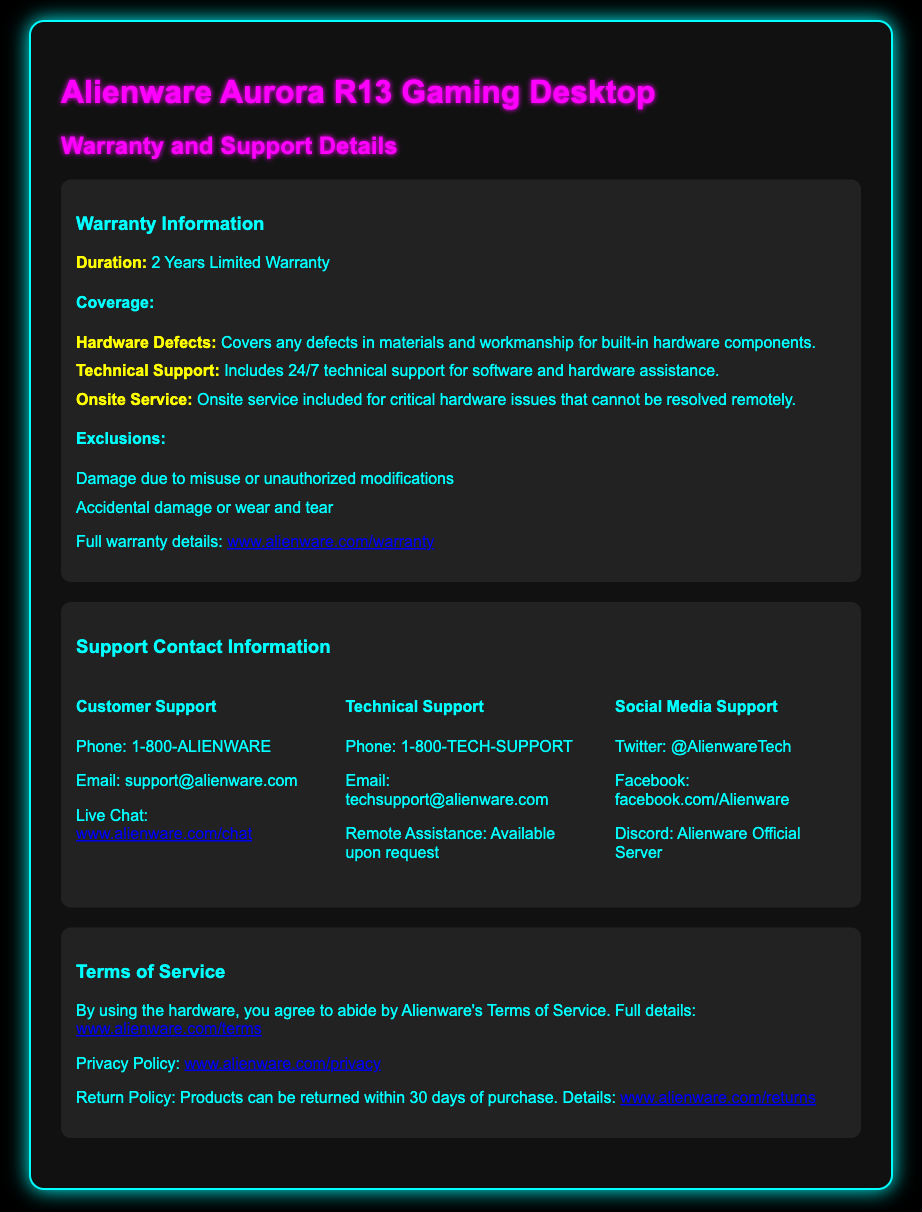What is the warranty duration? The warranty duration is specified in the document as 2 Years Limited Warranty.
Answer: 2 Years Limited Warranty What does the warranty cover? The document lists components covered by the warranty, including hardware defects and technical support.
Answer: Hardware Defects, Technical Support, Onsite Service What is excluded from the warranty coverage? The document outlines specific exclusions such as damage from misuse and accidental damage.
Answer: Damage due to misuse or unauthorized modifications, Accidental damage or wear and tear What is the phone number for Customer Support? The document provides the phone number for Customer Support as 1-800-ALIENWARE.
Answer: 1-800-ALIENWARE How many methods of contacting Technical Support are listed? The document includes various methods for contacting Technical Support including phone, email, and remote assistance.
Answer: 3 What is the return policy timeframe? The document specifies the timeframe for the return policy related to purchased products.
Answer: 30 days What does using the hardware require regarding Terms of Service? The document states that using the hardware requires agreement to Alienware's Terms of Service.
Answer: Agreement to Terms of Service Where can you find the full warranty details? The full warranty details can be found on the specified website link in the document.
Answer: www.alienware.com/warranty What is the email address for Technical Support? The document provides the email address for Technical Support as techsupport@alienware.com.
Answer: techsupport@alienware.com 